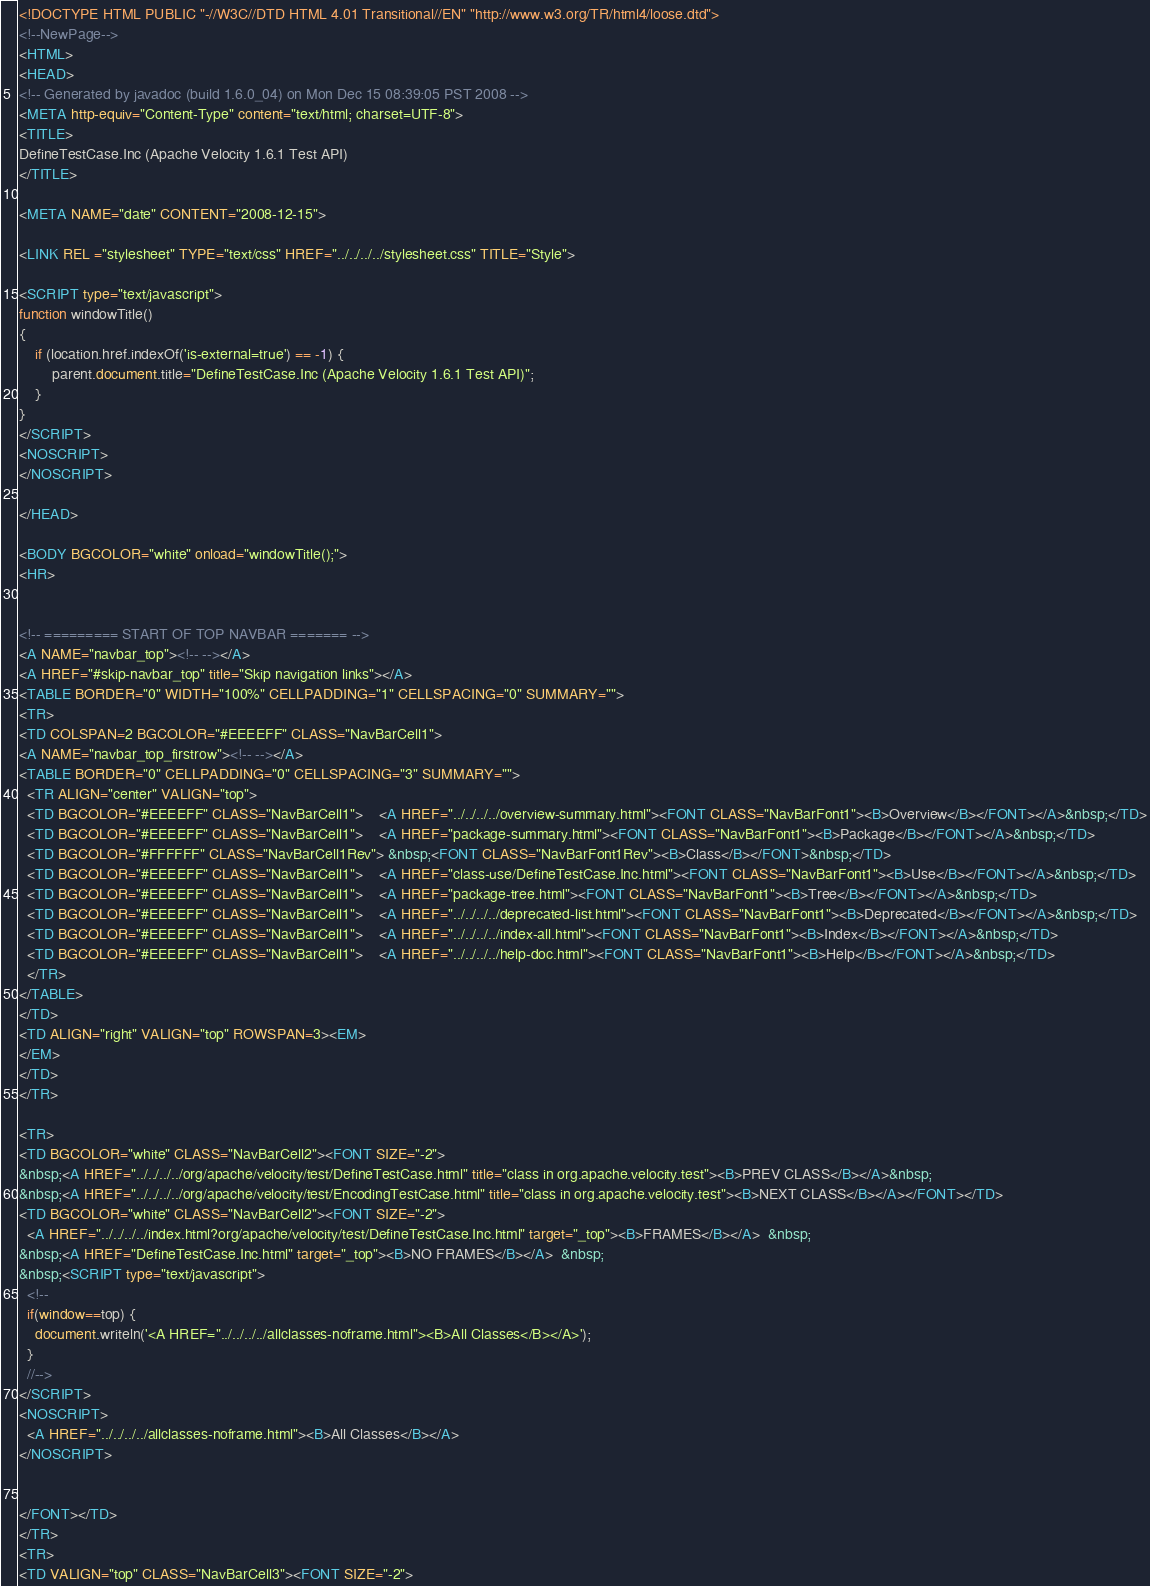Convert code to text. <code><loc_0><loc_0><loc_500><loc_500><_HTML_><!DOCTYPE HTML PUBLIC "-//W3C//DTD HTML 4.01 Transitional//EN" "http://www.w3.org/TR/html4/loose.dtd">
<!--NewPage-->
<HTML>
<HEAD>
<!-- Generated by javadoc (build 1.6.0_04) on Mon Dec 15 08:39:05 PST 2008 -->
<META http-equiv="Content-Type" content="text/html; charset=UTF-8">
<TITLE>
DefineTestCase.Inc (Apache Velocity 1.6.1 Test API)
</TITLE>

<META NAME="date" CONTENT="2008-12-15">

<LINK REL ="stylesheet" TYPE="text/css" HREF="../../../../stylesheet.css" TITLE="Style">

<SCRIPT type="text/javascript">
function windowTitle()
{
    if (location.href.indexOf('is-external=true') == -1) {
        parent.document.title="DefineTestCase.Inc (Apache Velocity 1.6.1 Test API)";
    }
}
</SCRIPT>
<NOSCRIPT>
</NOSCRIPT>

</HEAD>

<BODY BGCOLOR="white" onload="windowTitle();">
<HR>


<!-- ========= START OF TOP NAVBAR ======= -->
<A NAME="navbar_top"><!-- --></A>
<A HREF="#skip-navbar_top" title="Skip navigation links"></A>
<TABLE BORDER="0" WIDTH="100%" CELLPADDING="1" CELLSPACING="0" SUMMARY="">
<TR>
<TD COLSPAN=2 BGCOLOR="#EEEEFF" CLASS="NavBarCell1">
<A NAME="navbar_top_firstrow"><!-- --></A>
<TABLE BORDER="0" CELLPADDING="0" CELLSPACING="3" SUMMARY="">
  <TR ALIGN="center" VALIGN="top">
  <TD BGCOLOR="#EEEEFF" CLASS="NavBarCell1">    <A HREF="../../../../overview-summary.html"><FONT CLASS="NavBarFont1"><B>Overview</B></FONT></A>&nbsp;</TD>
  <TD BGCOLOR="#EEEEFF" CLASS="NavBarCell1">    <A HREF="package-summary.html"><FONT CLASS="NavBarFont1"><B>Package</B></FONT></A>&nbsp;</TD>
  <TD BGCOLOR="#FFFFFF" CLASS="NavBarCell1Rev"> &nbsp;<FONT CLASS="NavBarFont1Rev"><B>Class</B></FONT>&nbsp;</TD>
  <TD BGCOLOR="#EEEEFF" CLASS="NavBarCell1">    <A HREF="class-use/DefineTestCase.Inc.html"><FONT CLASS="NavBarFont1"><B>Use</B></FONT></A>&nbsp;</TD>
  <TD BGCOLOR="#EEEEFF" CLASS="NavBarCell1">    <A HREF="package-tree.html"><FONT CLASS="NavBarFont1"><B>Tree</B></FONT></A>&nbsp;</TD>
  <TD BGCOLOR="#EEEEFF" CLASS="NavBarCell1">    <A HREF="../../../../deprecated-list.html"><FONT CLASS="NavBarFont1"><B>Deprecated</B></FONT></A>&nbsp;</TD>
  <TD BGCOLOR="#EEEEFF" CLASS="NavBarCell1">    <A HREF="../../../../index-all.html"><FONT CLASS="NavBarFont1"><B>Index</B></FONT></A>&nbsp;</TD>
  <TD BGCOLOR="#EEEEFF" CLASS="NavBarCell1">    <A HREF="../../../../help-doc.html"><FONT CLASS="NavBarFont1"><B>Help</B></FONT></A>&nbsp;</TD>
  </TR>
</TABLE>
</TD>
<TD ALIGN="right" VALIGN="top" ROWSPAN=3><EM>
</EM>
</TD>
</TR>

<TR>
<TD BGCOLOR="white" CLASS="NavBarCell2"><FONT SIZE="-2">
&nbsp;<A HREF="../../../../org/apache/velocity/test/DefineTestCase.html" title="class in org.apache.velocity.test"><B>PREV CLASS</B></A>&nbsp;
&nbsp;<A HREF="../../../../org/apache/velocity/test/EncodingTestCase.html" title="class in org.apache.velocity.test"><B>NEXT CLASS</B></A></FONT></TD>
<TD BGCOLOR="white" CLASS="NavBarCell2"><FONT SIZE="-2">
  <A HREF="../../../../index.html?org/apache/velocity/test/DefineTestCase.Inc.html" target="_top"><B>FRAMES</B></A>  &nbsp;
&nbsp;<A HREF="DefineTestCase.Inc.html" target="_top"><B>NO FRAMES</B></A>  &nbsp;
&nbsp;<SCRIPT type="text/javascript">
  <!--
  if(window==top) {
    document.writeln('<A HREF="../../../../allclasses-noframe.html"><B>All Classes</B></A>');
  }
  //-->
</SCRIPT>
<NOSCRIPT>
  <A HREF="../../../../allclasses-noframe.html"><B>All Classes</B></A>
</NOSCRIPT>


</FONT></TD>
</TR>
<TR>
<TD VALIGN="top" CLASS="NavBarCell3"><FONT SIZE="-2"></code> 